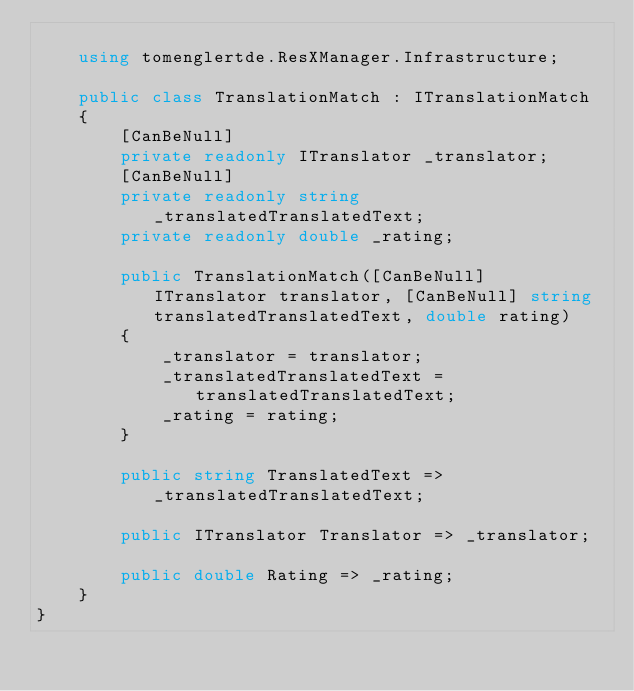<code> <loc_0><loc_0><loc_500><loc_500><_C#_>
    using tomenglertde.ResXManager.Infrastructure;

    public class TranslationMatch : ITranslationMatch
    {
        [CanBeNull]
        private readonly ITranslator _translator;
        [CanBeNull]
        private readonly string _translatedTranslatedText;
        private readonly double _rating;

        public TranslationMatch([CanBeNull] ITranslator translator, [CanBeNull] string translatedTranslatedText, double rating)
        {
            _translator = translator;
            _translatedTranslatedText = translatedTranslatedText;
            _rating = rating;
        }

        public string TranslatedText => _translatedTranslatedText;

        public ITranslator Translator => _translator;

        public double Rating => _rating;
    }
}</code> 